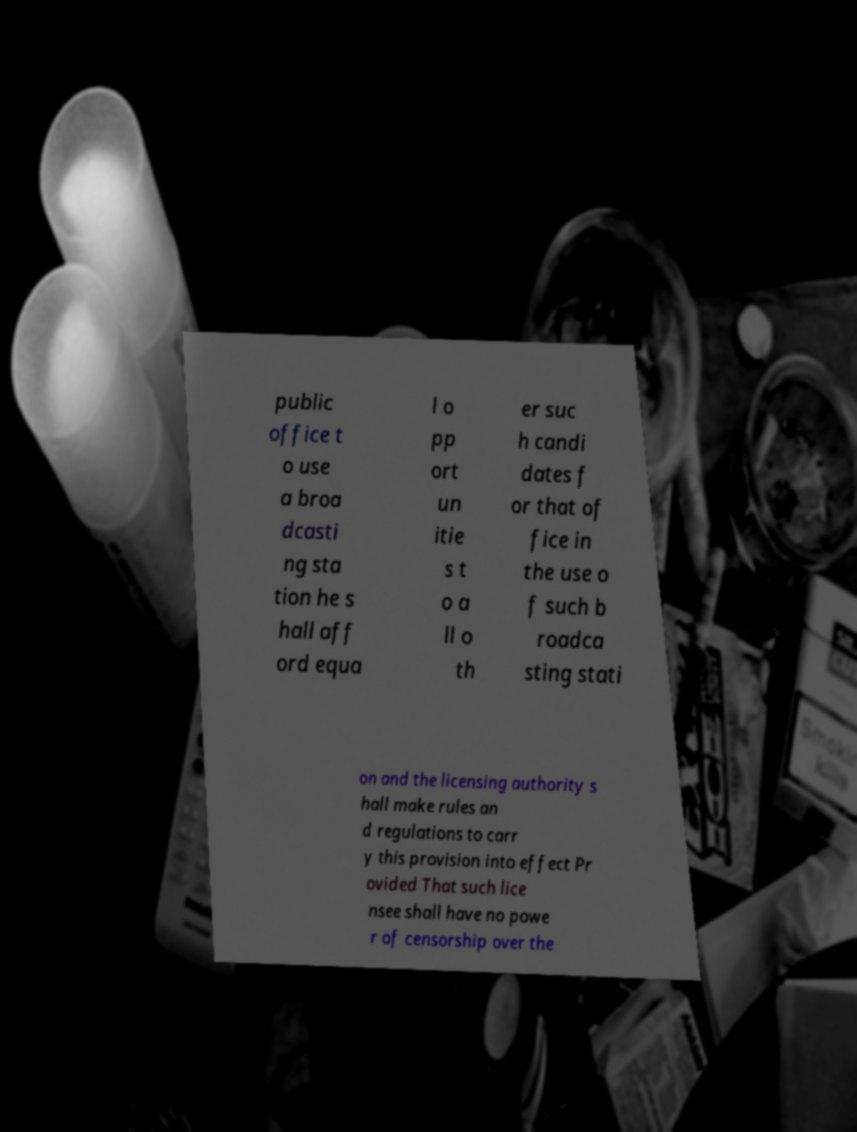Can you accurately transcribe the text from the provided image for me? public office t o use a broa dcasti ng sta tion he s hall aff ord equa l o pp ort un itie s t o a ll o th er suc h candi dates f or that of fice in the use o f such b roadca sting stati on and the licensing authority s hall make rules an d regulations to carr y this provision into effect Pr ovided That such lice nsee shall have no powe r of censorship over the 